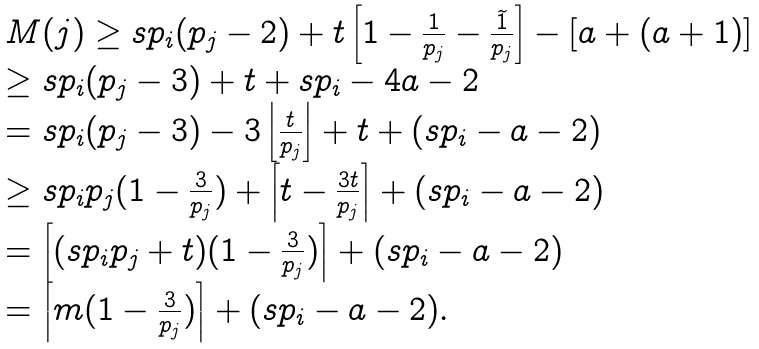<formula> <loc_0><loc_0><loc_500><loc_500>\begin{array} { l } M ( j ) \geq s p _ { i } ( p _ { j } - 2 ) + t \left [ 1 - \frac { 1 } { p _ { j } } - \frac { \widetilde { 1 } } { p _ { j } } \right ] - [ a + ( a + 1 ) ] \\ \geq s p _ { i } ( p _ { j } - 3 ) + t + s p _ { i } - 4 a - 2 \\ = s p _ { i } ( p _ { j } - 3 ) - 3 \left \lfloor \frac { t } { p _ { j } } \right \rfloor + t + ( s p _ { i } - a - 2 ) \\ \geq s p _ { i } p _ { j } ( 1 - \frac { 3 } { p _ { j } } ) + \left \lceil t - \frac { 3 t } { p _ { j } } \right \rceil + ( s p _ { i } - a - 2 ) \\ = \left \lceil ( s p _ { i } p _ { j } + t ) ( 1 - \frac { 3 } { p _ { j } } ) \right \rceil + ( s p _ { i } - a - 2 ) \\ = \left \lceil m ( 1 - \frac { 3 } { p _ { j } } ) \right \rceil + ( s p _ { i } - a - 2 ) . \end{array}</formula> 